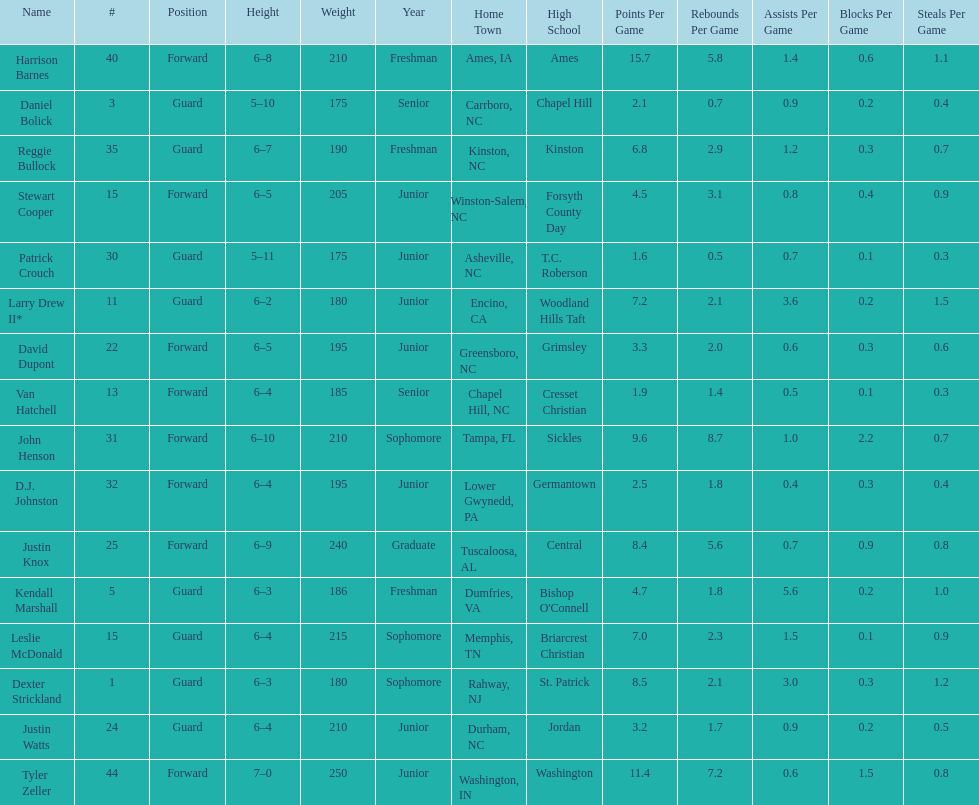Names of players who were exactly 6 feet, 4 inches tall, but did not weight over 200 pounds Van Hatchell, D.J. Johnston. 